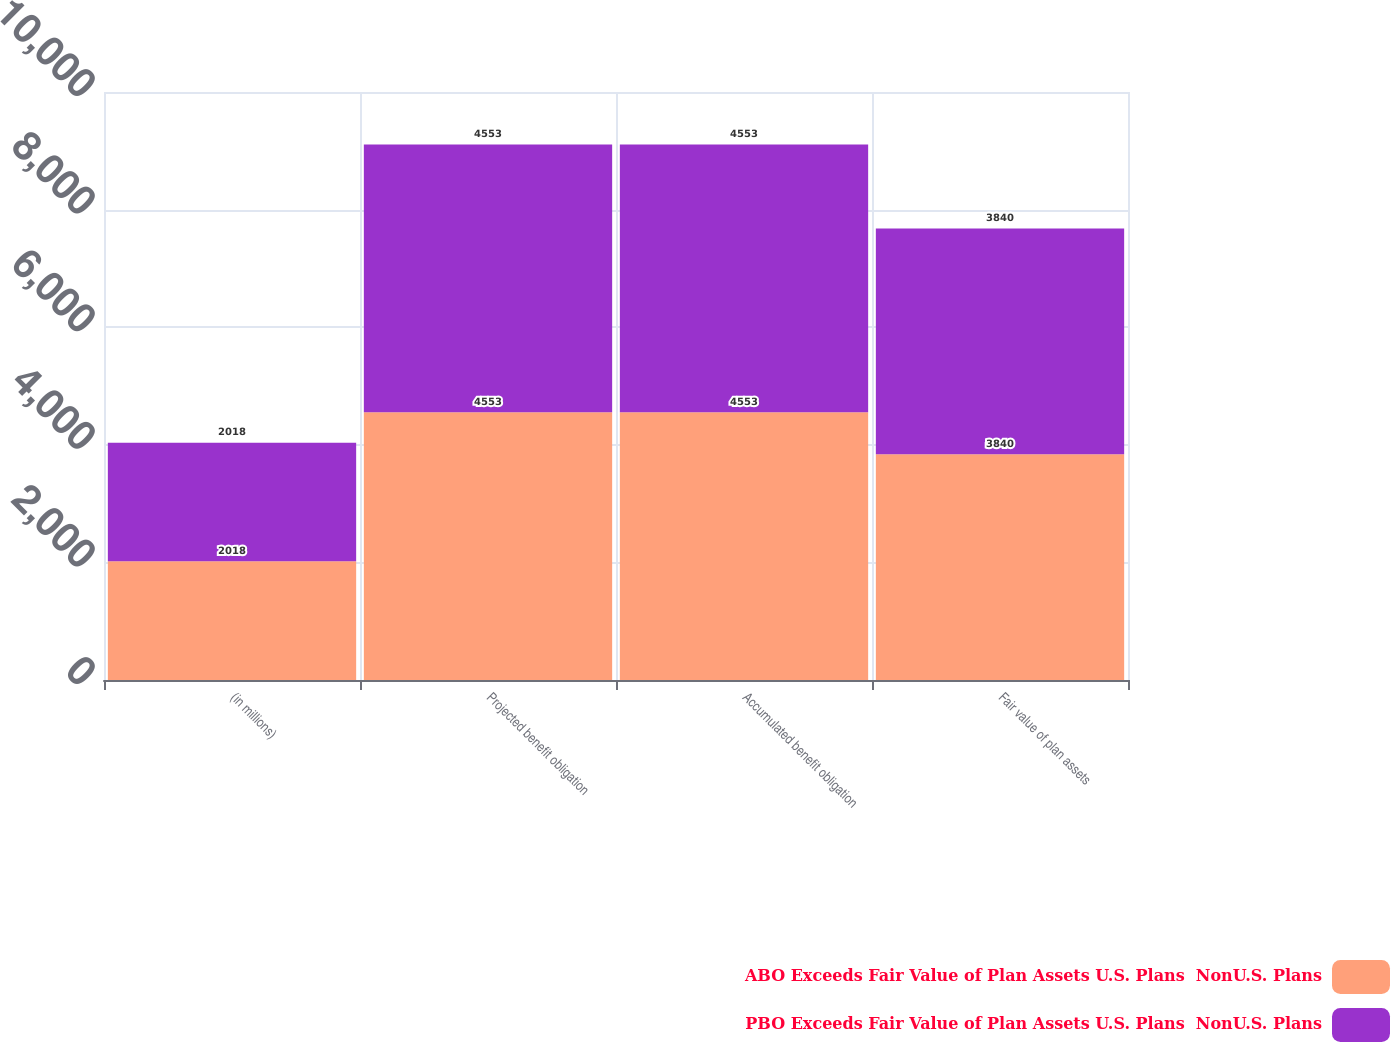Convert chart. <chart><loc_0><loc_0><loc_500><loc_500><stacked_bar_chart><ecel><fcel>(in millions)<fcel>Projected benefit obligation<fcel>Accumulated benefit obligation<fcel>Fair value of plan assets<nl><fcel>ABO Exceeds Fair Value of Plan Assets U.S. Plans  NonU.S. Plans<fcel>2018<fcel>4553<fcel>4553<fcel>3840<nl><fcel>PBO Exceeds Fair Value of Plan Assets U.S. Plans  NonU.S. Plans<fcel>2018<fcel>4553<fcel>4553<fcel>3840<nl></chart> 